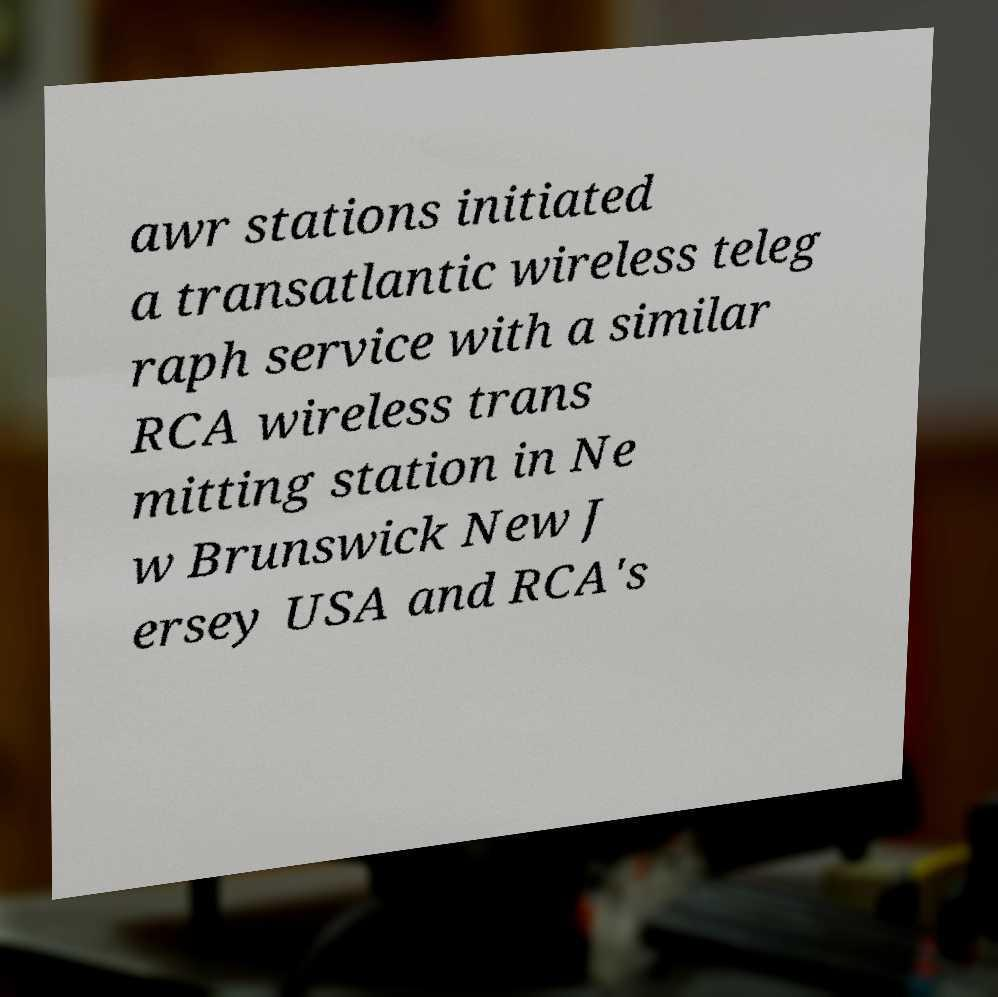There's text embedded in this image that I need extracted. Can you transcribe it verbatim? awr stations initiated a transatlantic wireless teleg raph service with a similar RCA wireless trans mitting station in Ne w Brunswick New J ersey USA and RCA's 